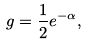<formula> <loc_0><loc_0><loc_500><loc_500>g = \frac { 1 } { 2 } e ^ { - \alpha } ,</formula> 